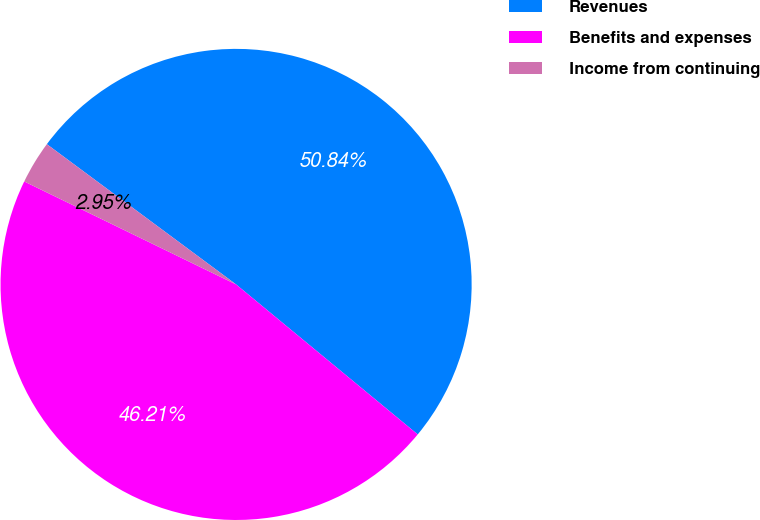<chart> <loc_0><loc_0><loc_500><loc_500><pie_chart><fcel>Revenues<fcel>Benefits and expenses<fcel>Income from continuing<nl><fcel>50.83%<fcel>46.21%<fcel>2.95%<nl></chart> 